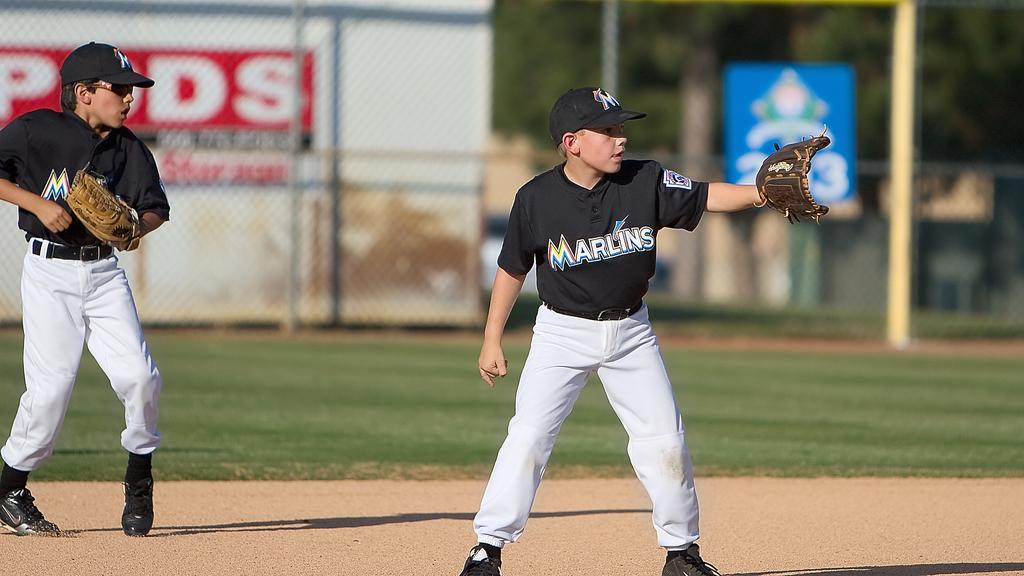<image>
Write a terse but informative summary of the picture. 2 men playing basball with marlins written across 